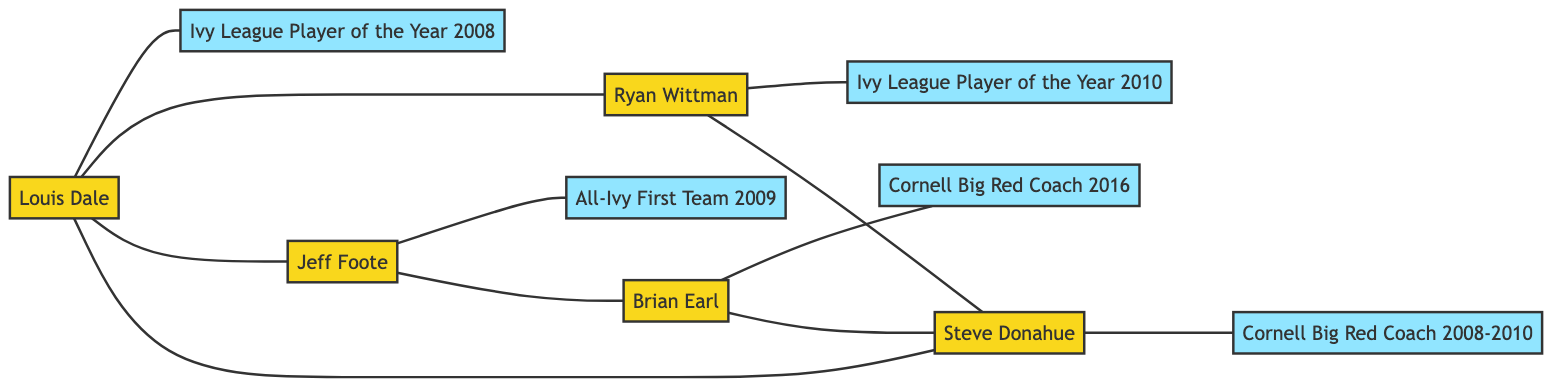What player achieved the Ivy League Player of the Year in 2008? The diagram indicates that Louis Dale is linked to the achievement node "Ivy League Player of the Year 2008." Therefore, he is the player who achieved this honor.
Answer: Louis Dale How many players are shown in the diagram? There are five players in the diagram: Louis Dale, Ryan Wittman, Jeff Foote, Brian Earl, and Steve Donahue. Counting each player listed gives us a total of five.
Answer: 5 Which achievement is linked to Jeff Foote? The diagram clearly shows that Jeff Foote is linked to the achievement node "All-Ivy First Team 2009," signifying his accomplishment.
Answer: All-Ivy First Team 2009 What is the relationship between Brian Earl and Jeff Foote? The diagram illustrates a direct link between Brian Earl and Jeff Foote. Therefore, they have a direct connection in terms of their basketball achievements.
Answer: Direct connection Which player is connected to the most achievements? By examining the links, Steve Donahue has three connections: to Ryan Wittman, Louis Dale, and Brian Earl, indicating he is involved with the most players related to achievements.
Answer: Steve Donahue What major role did Brian Earl have in 2016? According to the diagram, Brian Earl is linked to the achievement "Cornell Big Red Coach 2016," indicating his significant role in that year.
Answer: Cornell Big Red Coach 2016 Which two players are connected through Ryan Wittman? The diagram shows that Ryan Wittman is directly linked to Louis Dale and Steve Donahue. This means both of these players are connected through Ryan Wittman.
Answer: Louis Dale and Steve Donahue What is the total number of achievements listed in the diagram? The diagram features five achievement nodes: "Ivy League Player of the Year 2008," "Ivy League Player of the Year 2010," "All-Ivy First Team 2009," "Cornell Big Red Coach 2016," and "Cornell Big Red Coach 2008-2010." Counting these gives us a total of five achievements.
Answer: 5 Which player did not coach in 2008-2010? The diagram indicates that Louis Dale, Ryan Wittman, and Jeff Foote are players who do not hold coach titles during the period of 2008-2010, while Steve Donahue did serve as a coach during that timeframe.
Answer: Louis Dale, Ryan Wittman, and Jeff Foote 